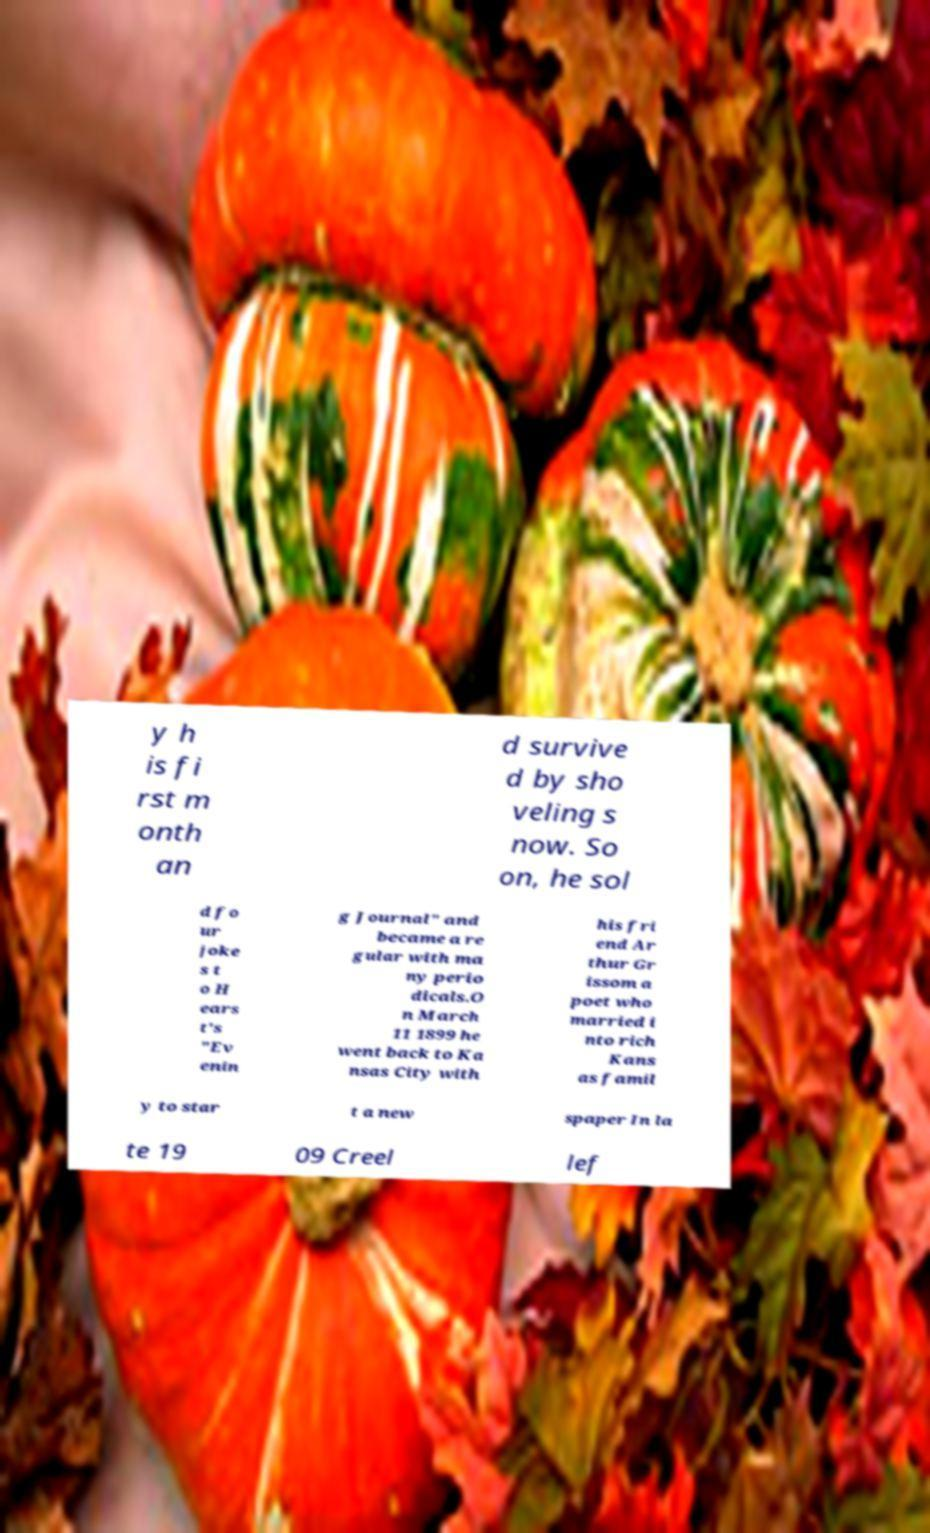Can you read and provide the text displayed in the image?This photo seems to have some interesting text. Can you extract and type it out for me? y h is fi rst m onth an d survive d by sho veling s now. So on, he sol d fo ur joke s t o H ears t's "Ev enin g Journal" and became a re gular with ma ny perio dicals.O n March 11 1899 he went back to Ka nsas City with his fri end Ar thur Gr issom a poet who married i nto rich Kans as famil y to star t a new spaper In la te 19 09 Creel lef 